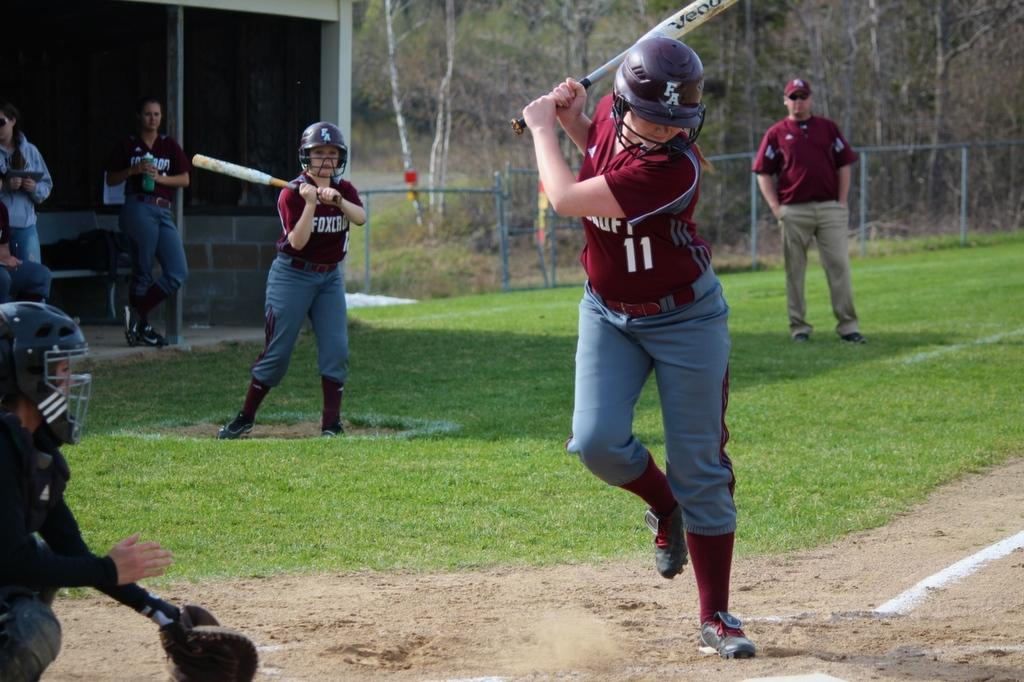<image>
Create a compact narrative representing the image presented. a person with the number 11 on their jersey in daytime playing baseball 